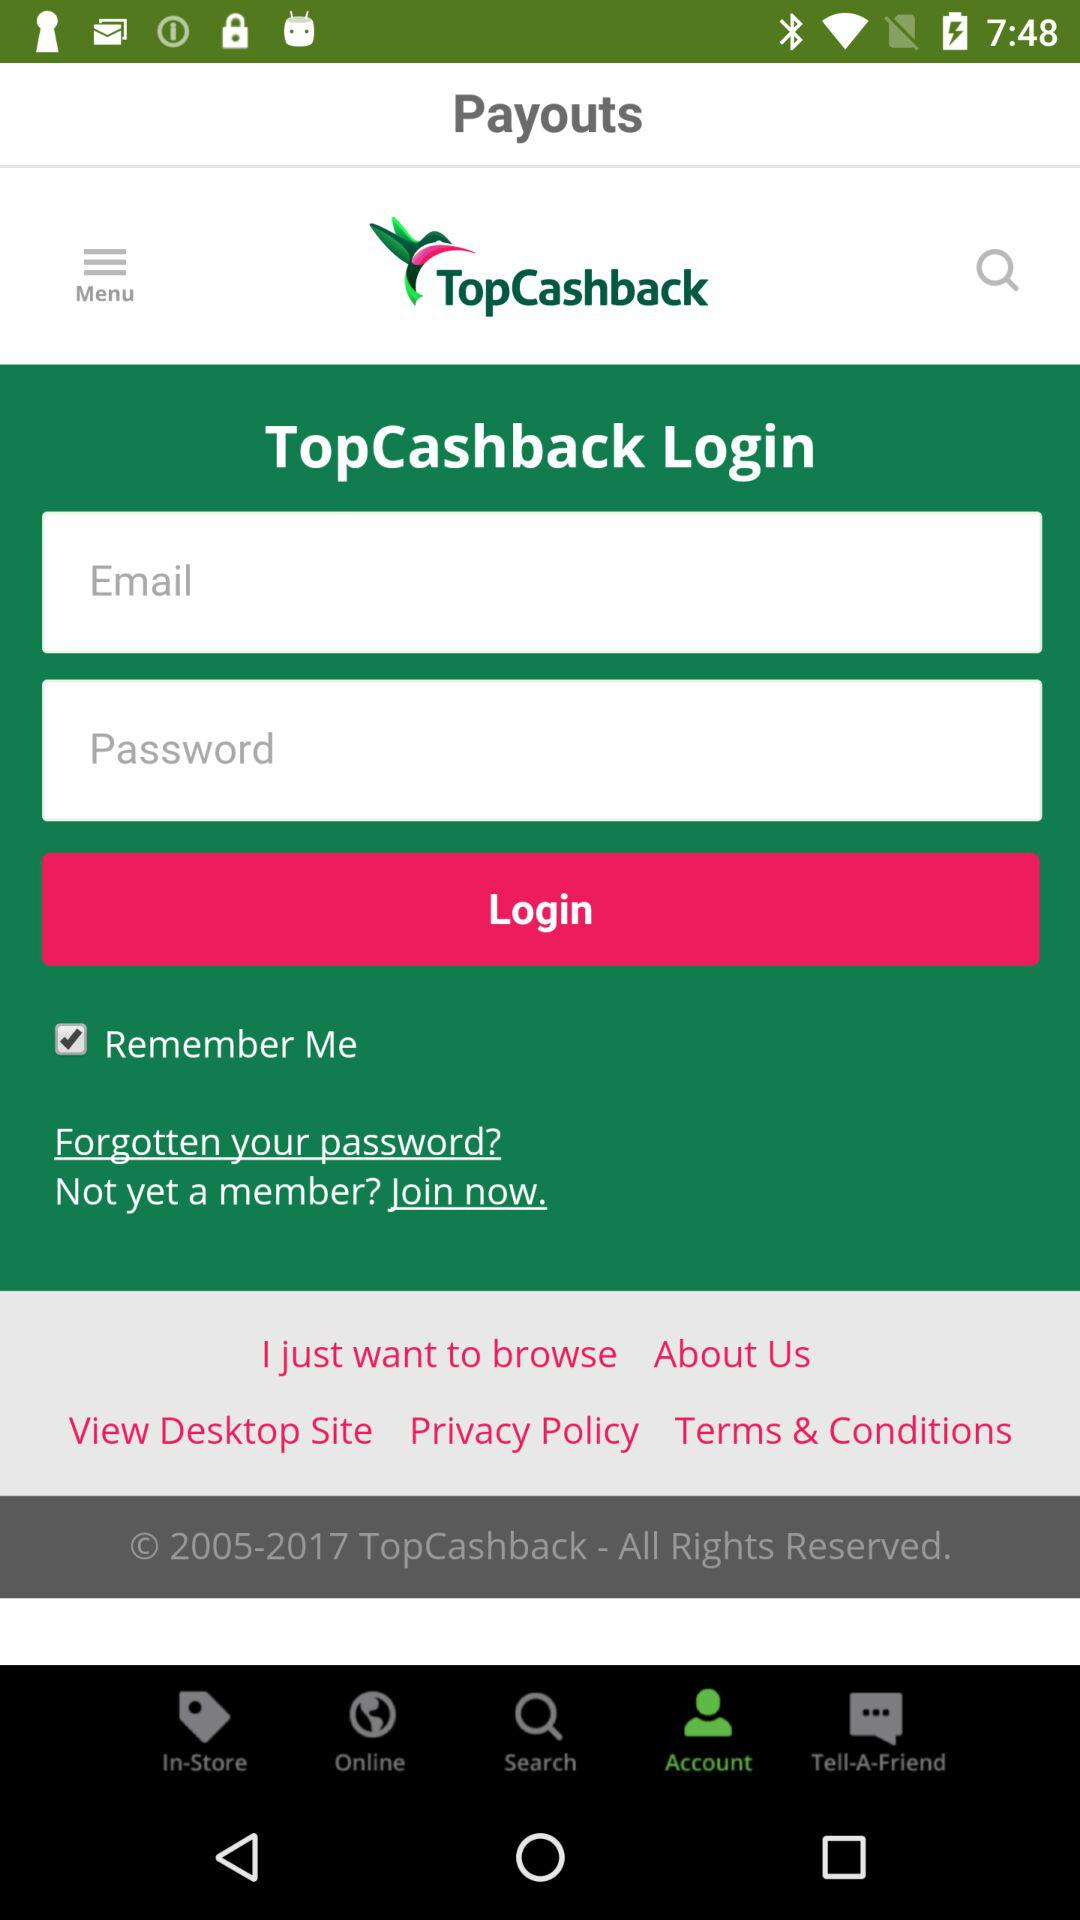What is the name of the application? The name of the application is "TopCashback". 